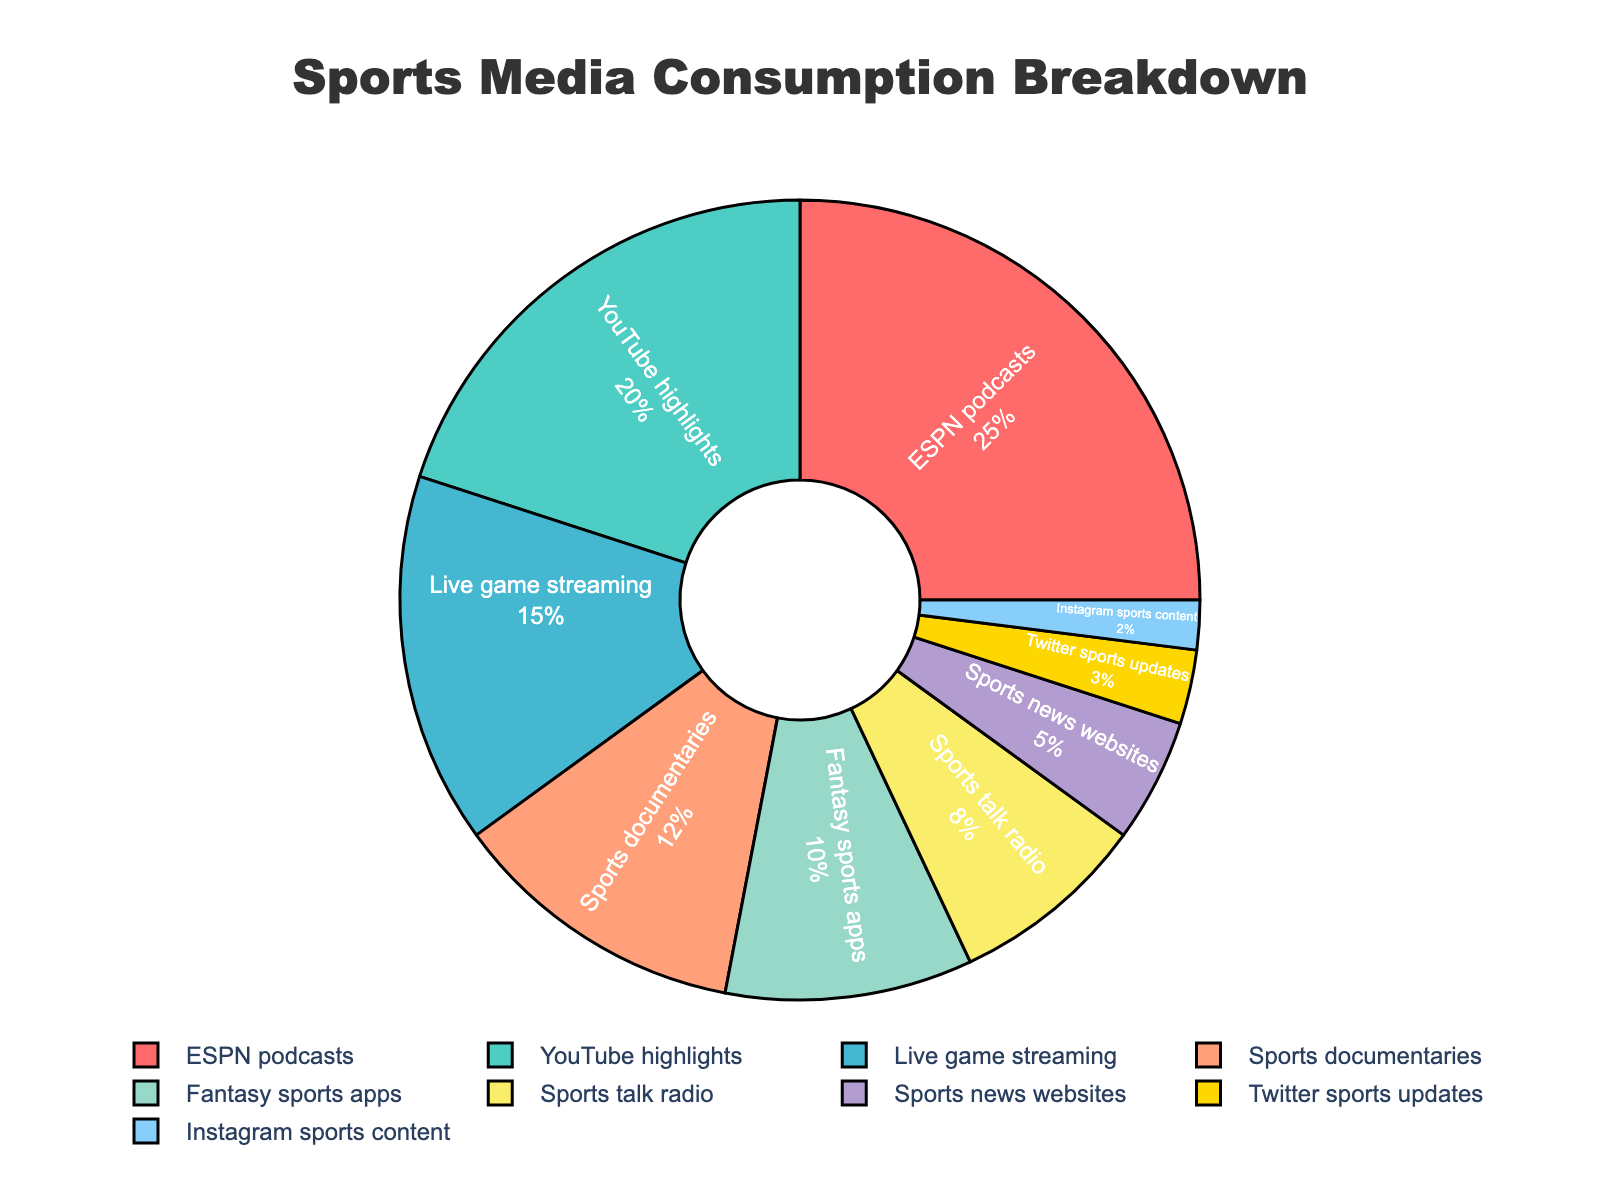What percentage of time is spent on ESPN podcasts? The pie chart shows various segments representing different media types along with their respective percentages. The segment labeled "ESPN podcasts" indicates the time spent.
Answer: 25% How much more time is spent on YouTube highlights compared to Instagram sports content? The chart shows that 20% of time is spent on YouTube highlights and 2% on Instagram sports content. To find the difference, subtract the smaller percentage from the larger one: 20% - 2% = 18%.
Answer: 18% What is the total percentage of time spent on live game streaming, sports documentaries, and fantasy sports apps combined? Add the percentages for live game streaming (15%), sports documentaries (12%), and fantasy sports apps (10%): 15% + 12% + 10% = 37%.
Answer: 37% Which media type occupies the smallest share of time, and what is its percentage? The chart shows various segments with their percentages. The smallest segment represents Instagram sports content with 2%.
Answer: Instagram sports content, 2% Is the time spent on sports talk radio greater than that on sports news websites? Check the percentages for sports talk radio (8%) and sports news websites (5%). Since 8% is greater than 5%, the time spent on sports talk radio is indeed greater.
Answer: Yes What is the percentage difference between the time spent on sports news websites and Twitter sports updates? Subtract the percentage of Twitter sports updates (3%) from that of sports news websites (5%): 5% - 3% = 2%.
Answer: 2% What colors are used to represent sports talk radio and ESPN podcasts on the chart? The pie chart uses distinct colors for each segment. Find the segments labeled "Sports talk radio" and "ESPN podcasts" to identify their colors. Sports talk radio is shown in a yellowish color, and ESPN podcasts in red.
Answer: Yellowish, Red How does the percentage of time spent on fantasy sports apps compare to that on YouTube highlights? The percentage of time spent on fantasy sports apps (10%) is compared to that on YouTube highlights (20%). Since 10% is less than 20%, less time is spent on fantasy sports apps compared to YouTube highlights.
Answer: Less What is the total percentage of time spent on YouTube highlights, live game streaming, and ESPN podcasts together? Add the percentages for YouTube highlights (20%), live game streaming (15%), and ESPN podcasts (25%): 20% + 15% + 25% = 60%.
Answer: 60% Which media type occupies a larger share of time: live game streaming or sports documentaries? Compare the percentages for live game streaming (15%) and sports documentaries (12%). Since 15% is greater than 12%, live game streaming occupies a larger share of time.
Answer: Live game streaming 